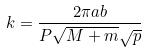<formula> <loc_0><loc_0><loc_500><loc_500>k = \frac { 2 \pi a b } { P \sqrt { M + m } \sqrt { p } }</formula> 